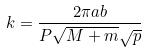<formula> <loc_0><loc_0><loc_500><loc_500>k = \frac { 2 \pi a b } { P \sqrt { M + m } \sqrt { p } }</formula> 